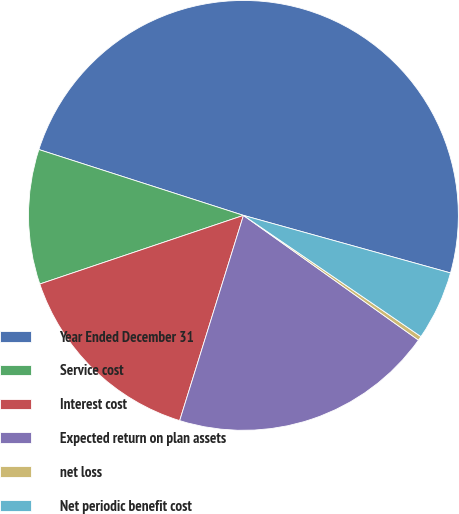Convert chart. <chart><loc_0><loc_0><loc_500><loc_500><pie_chart><fcel>Year Ended December 31<fcel>Service cost<fcel>Interest cost<fcel>Expected return on plan assets<fcel>net loss<fcel>Net periodic benefit cost<nl><fcel>49.36%<fcel>10.13%<fcel>15.03%<fcel>19.94%<fcel>0.32%<fcel>5.22%<nl></chart> 